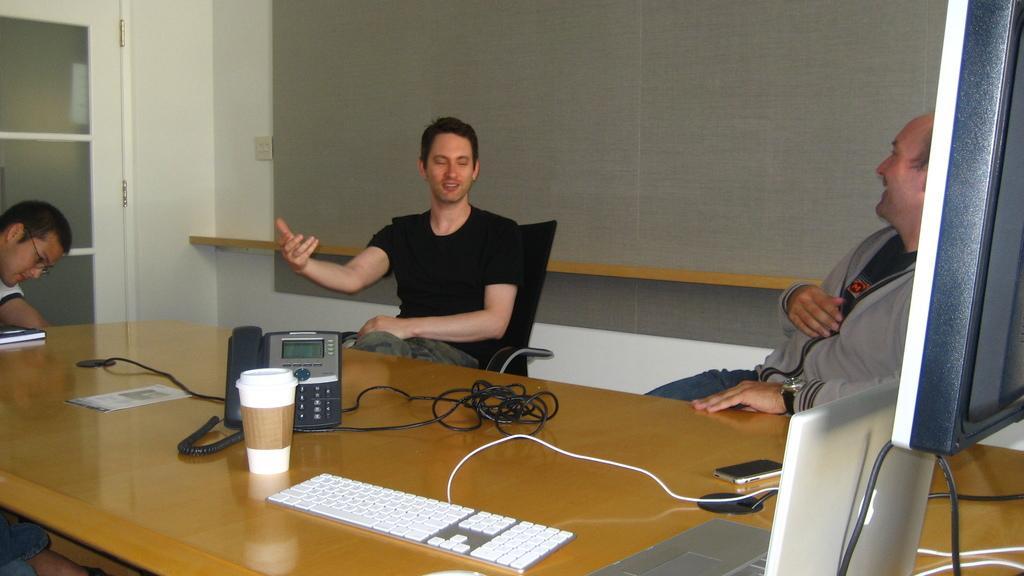Could you give a brief overview of what you see in this image? It's a meeting room, there is a big brown color table on which the telephone ,a keyboard ,monitor ,laptop ,mobile phone ,Cup is held to the three sets of table there are three people sitting they are talking with each other in the background there is a grey color wall beside it there is a door. 